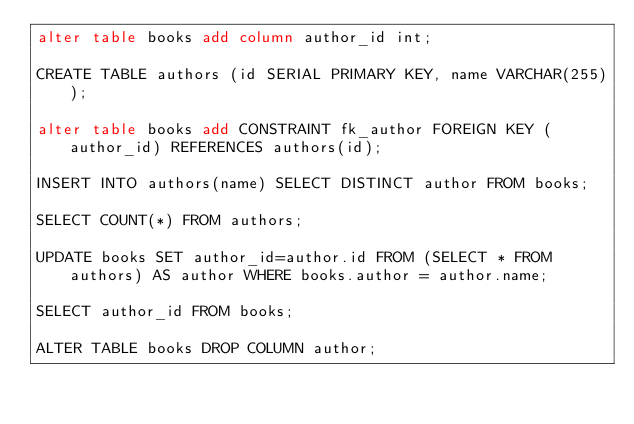Convert code to text. <code><loc_0><loc_0><loc_500><loc_500><_SQL_>alter table books add column author_id int;

CREATE TABLE authors (id SERIAL PRIMARY KEY, name VARCHAR(255));

alter table books add CONSTRAINT fk_author FOREIGN KEY (author_id) REFERENCES authors(id);

INSERT INTO authors(name) SELECT DISTINCT author FROM books;

SELECT COUNT(*) FROM authors;

UPDATE books SET author_id=author.id FROM (SELECT * FROM authors) AS author WHERE books.author = author.name;

SELECT author_id FROM books; 

ALTER TABLE books DROP COLUMN author;</code> 